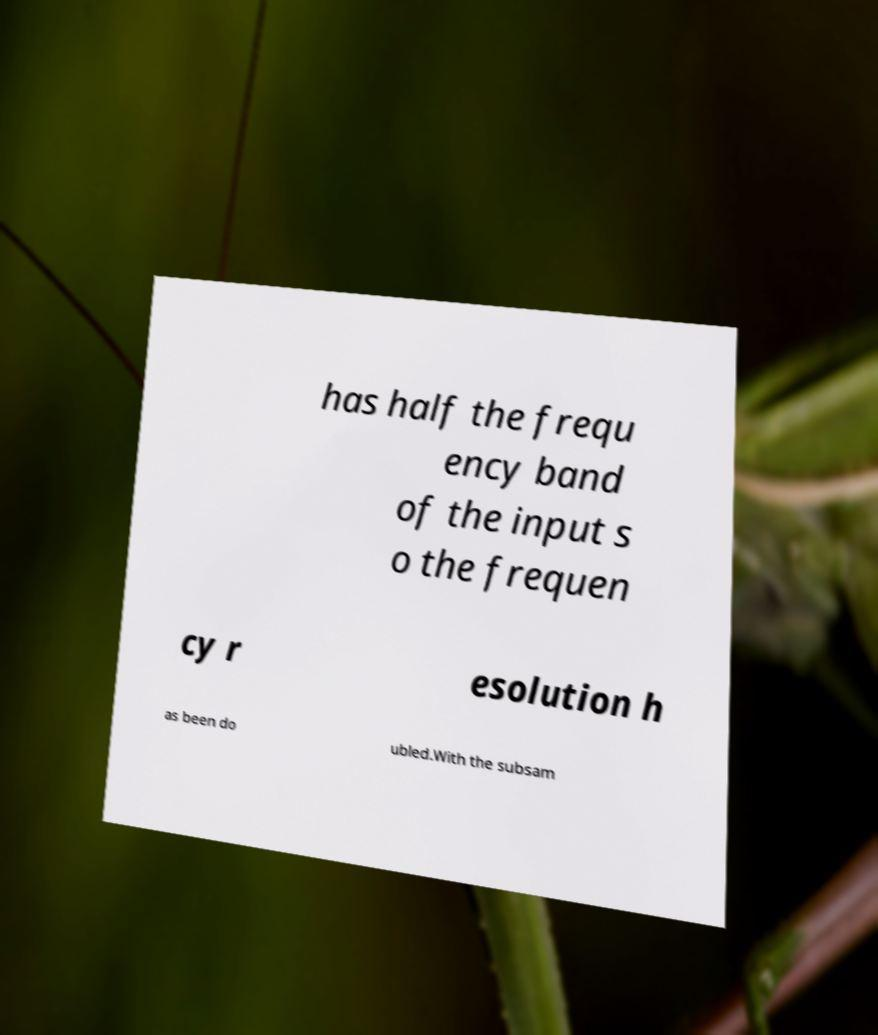Could you extract and type out the text from this image? has half the frequ ency band of the input s o the frequen cy r esolution h as been do ubled.With the subsam 